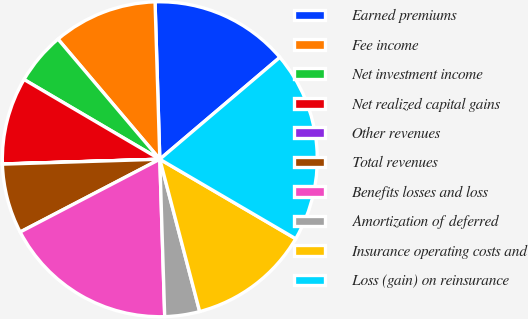Convert chart to OTSL. <chart><loc_0><loc_0><loc_500><loc_500><pie_chart><fcel>Earned premiums<fcel>Fee income<fcel>Net investment income<fcel>Net realized capital gains<fcel>Other revenues<fcel>Total revenues<fcel>Benefits losses and loss<fcel>Amortization of deferred<fcel>Insurance operating costs and<fcel>Loss (gain) on reinsurance<nl><fcel>14.28%<fcel>10.71%<fcel>5.36%<fcel>8.93%<fcel>0.02%<fcel>7.15%<fcel>17.85%<fcel>3.58%<fcel>12.5%<fcel>19.63%<nl></chart> 